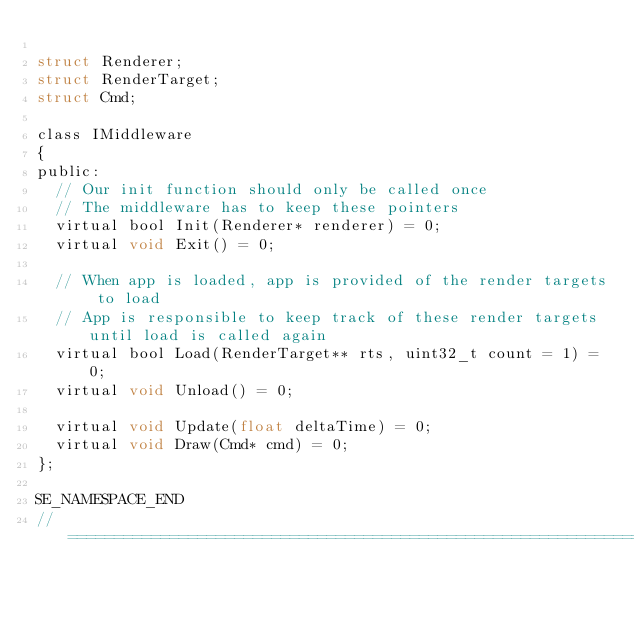Convert code to text. <code><loc_0><loc_0><loc_500><loc_500><_C_>
struct Renderer;
struct RenderTarget;
struct Cmd;

class IMiddleware
{
public:
	// Our init function should only be called once
	// The middleware has to keep these pointers
	virtual bool Init(Renderer* renderer) = 0;
	virtual void Exit() = 0;

	// When app is loaded, app is provided of the render targets to load
	// App is responsible to keep track of these render targets until load is called again
	virtual bool Load(RenderTarget** rts, uint32_t count = 1) = 0;
	virtual void Unload() = 0;

	virtual void Update(float deltaTime) = 0;
	virtual void Draw(Cmd* cmd) = 0;
};

SE_NAMESPACE_END
//=============================================================================</code> 